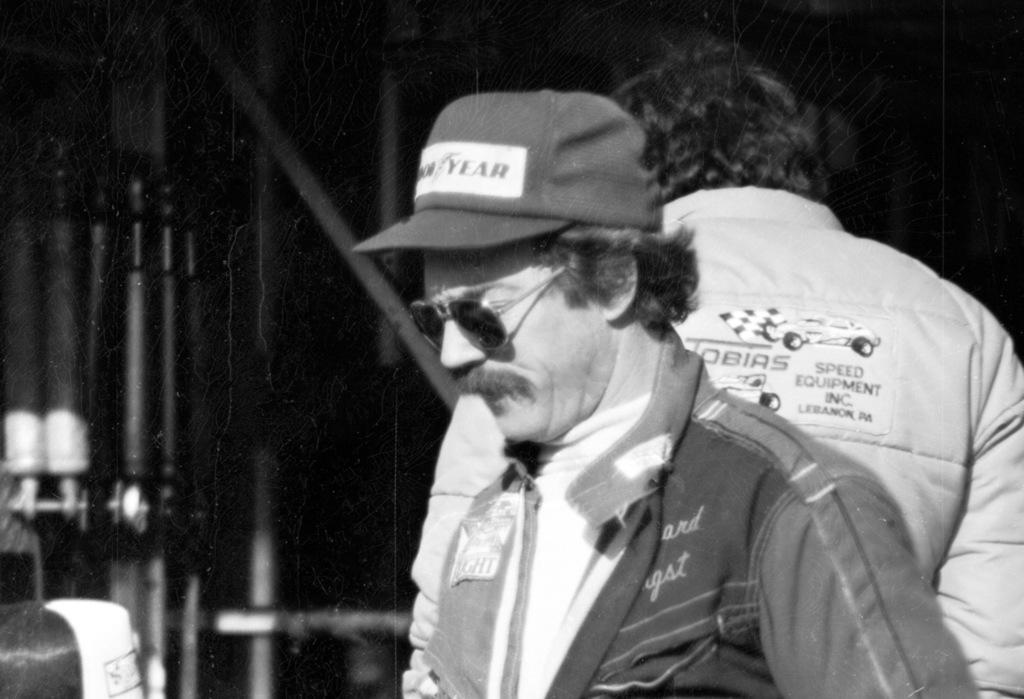What is the color scheme of the image? The image is black and white. Who is present in the image? There are men standing in the image. What can be seen in the background of the image? There are grills in the background of the image. Where is the shelf located in the image? There is no shelf present in the image. What type of field is visible in the image? There is no field visible in the image. 